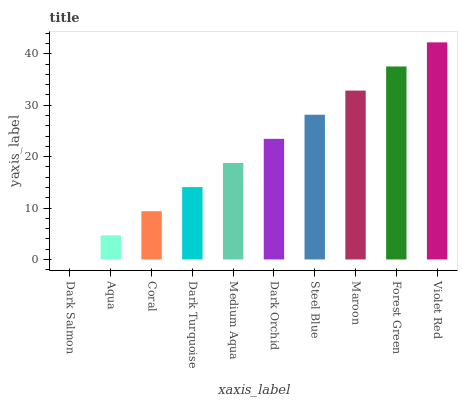Is Aqua the minimum?
Answer yes or no. No. Is Aqua the maximum?
Answer yes or no. No. Is Aqua greater than Dark Salmon?
Answer yes or no. Yes. Is Dark Salmon less than Aqua?
Answer yes or no. Yes. Is Dark Salmon greater than Aqua?
Answer yes or no. No. Is Aqua less than Dark Salmon?
Answer yes or no. No. Is Dark Orchid the high median?
Answer yes or no. Yes. Is Medium Aqua the low median?
Answer yes or no. Yes. Is Aqua the high median?
Answer yes or no. No. Is Dark Orchid the low median?
Answer yes or no. No. 